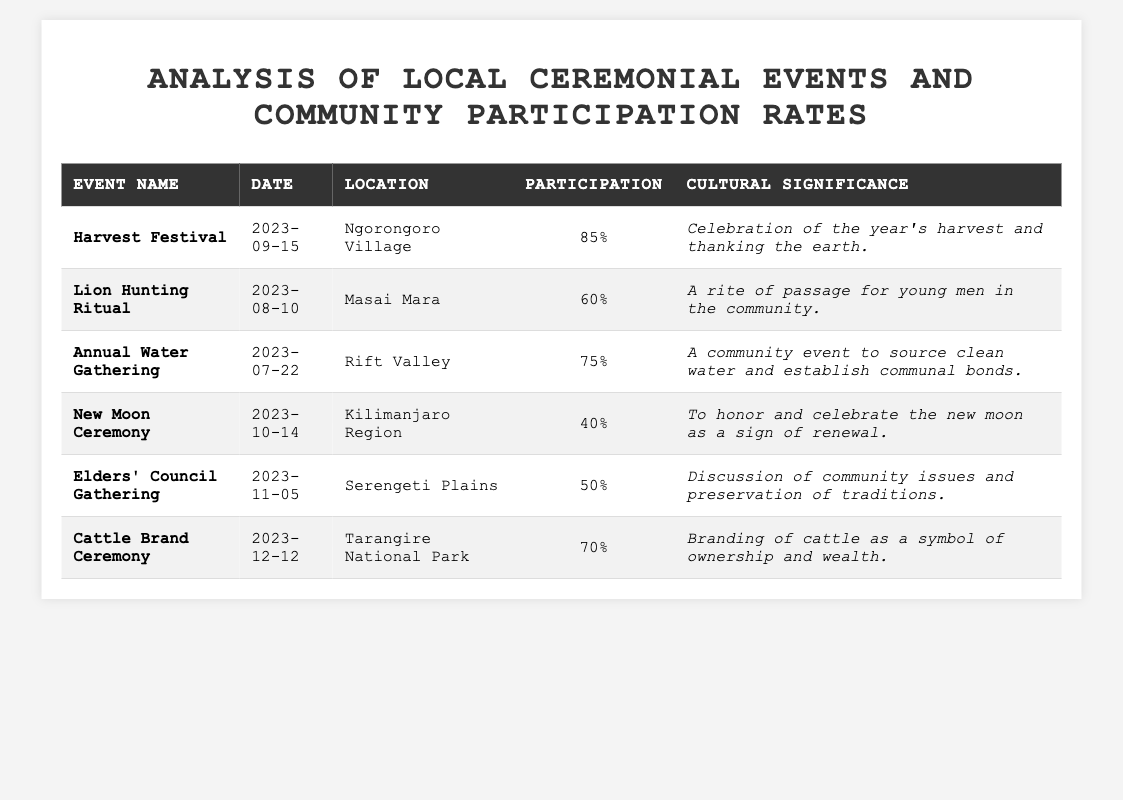What is the date of the Harvest Festival? The table lists the date for the Harvest Festival under the "Date" column next to its name in the "Event Name" column. The date is 2023-09-15.
Answer: 2023-09-15 Which event has the highest community participation? By comparing the percentages in the "Participation" column, the highest is 85% for the Harvest Festival.
Answer: Harvest Festival Was the Lion Hunting Ritual held before or after the Annual Water Gathering? The Lion Hunting Ritual is on 2023-08-10 and the Annual Water Gathering is on 2023-07-22. Since August comes after July, the Lion Hunting Ritual was held after the Annual Water Gathering.
Answer: After What percentage of community participation did the New Moon Ceremony have? The "Participation" column indicates that the New Moon Ceremony had a community participation of 40%.
Answer: 40% What is the cultural significance of the Cattle Brand Ceremony? The significance is specified in the "Cultural Significance" column, where it states that it symbolizes ownership and wealth through branding cattle.
Answer: Branding of cattle as a symbol of ownership and wealth Calculate the average community participation of all events listed. To find the average, add the participation percentages: (85 + 60 + 75 + 40 + 50 + 70) = 410. Then, divide by the number of events (6): 410 / 6 = 68.33. Thus, the average participation is approximately 68.33%.
Answer: 68.33% Is the participation rate for the Elders' Council Gathering greater than or equal to 50%? The participation rate for the Elders' Council Gathering is listed as 50%. Since the question asks if it is greater than or equal to 50%, it holds true.
Answer: Yes How many events have participation rates below 60%? By examining the "Participation" column, we can identify that the New Moon Ceremony (40%) and the Elders' Council Gathering (50%) have participation rates below 60%, making a total of 2 events.
Answer: 2 What event took place at Tarangire National Park? The "Location" column shows that the Cattle Brand Ceremony took place at Tarangire National Park.
Answer: Cattle Brand Ceremony Which event has the lowest participation rate? By checking the "Participation" percentages, the New Moon Ceremony has the lowest rate at 40%.
Answer: New Moon Ceremony What is the difference in participation rates between the Harvest Festival and the Lion Hunting Ritual? The percentages for the two events are 85% for the Harvest Festival and 60% for the Lion Hunting Ritual. The difference is calculated as 85 - 60 = 25%.
Answer: 25% 